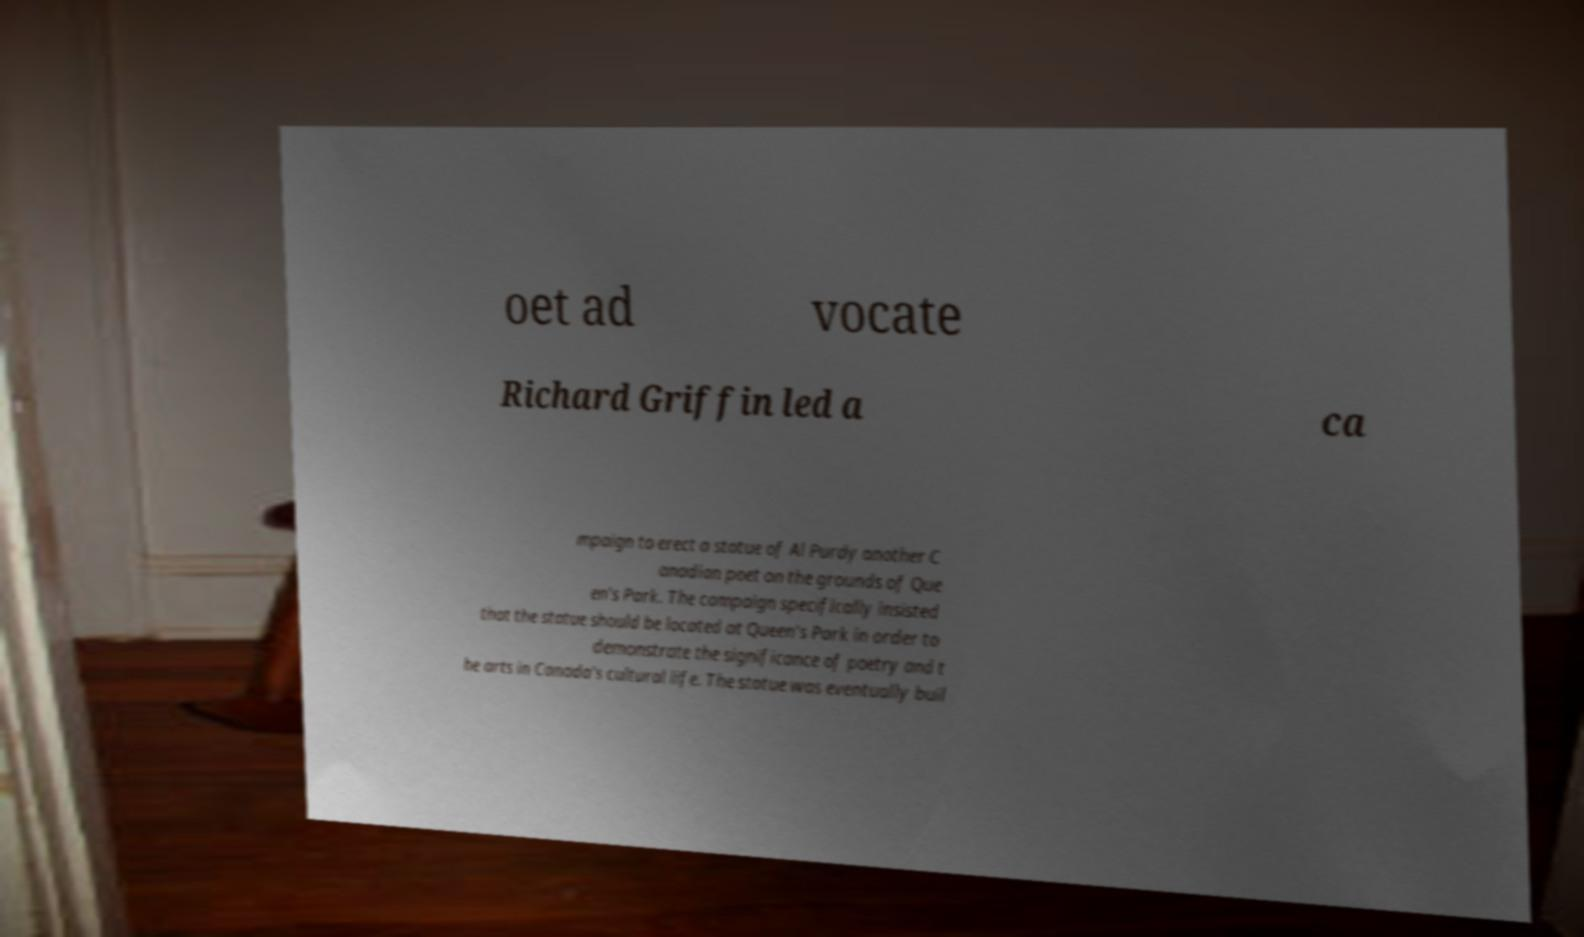Can you read and provide the text displayed in the image?This photo seems to have some interesting text. Can you extract and type it out for me? oet ad vocate Richard Griffin led a ca mpaign to erect a statue of Al Purdy another C anadian poet on the grounds of Que en's Park. The campaign specifically insisted that the statue should be located at Queen's Park in order to demonstrate the significance of poetry and t he arts in Canada's cultural life. The statue was eventually buil 